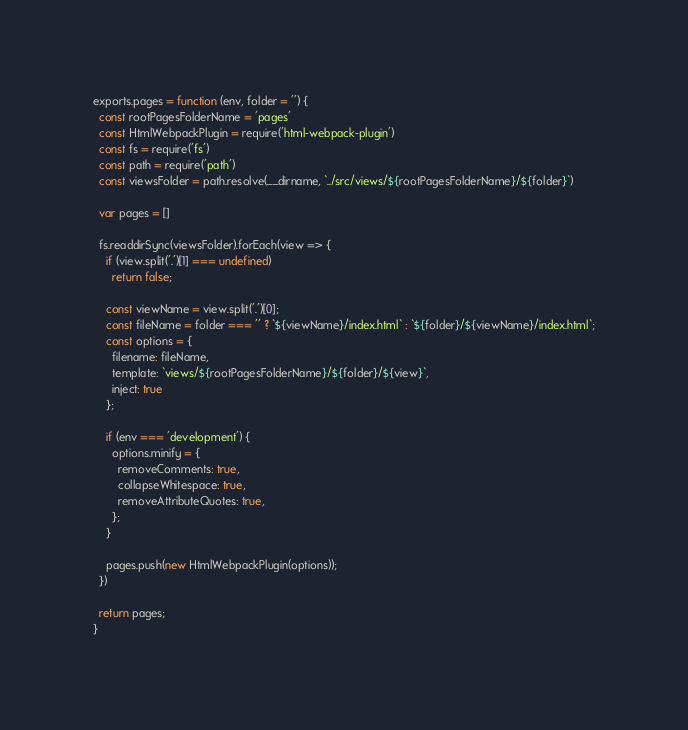Convert code to text. <code><loc_0><loc_0><loc_500><loc_500><_JavaScript_>exports.pages = function (env, folder = '') {
  const rootPagesFolderName = 'pages'
  const HtmlWebpackPlugin = require('html-webpack-plugin')
  const fs = require('fs')
  const path = require('path')
  const viewsFolder = path.resolve(__dirname, `../src/views/${rootPagesFolderName}/${folder}`)

  var pages = []

  fs.readdirSync(viewsFolder).forEach(view => {
    if (view.split('.')[1] === undefined)
      return false;

    const viewName = view.split('.')[0];
    const fileName = folder === '' ? `${viewName}/index.html` : `${folder}/${viewName}/index.html`;
    const options = {
      filename: fileName,
      template: `views/${rootPagesFolderName}/${folder}/${view}`,
      inject: true
    };

    if (env === 'development') {
      options.minify = {
        removeComments: true,
        collapseWhitespace: true,
        removeAttributeQuotes: true,
      };
    }

    pages.push(new HtmlWebpackPlugin(options));
  })

  return pages;
}
</code> 